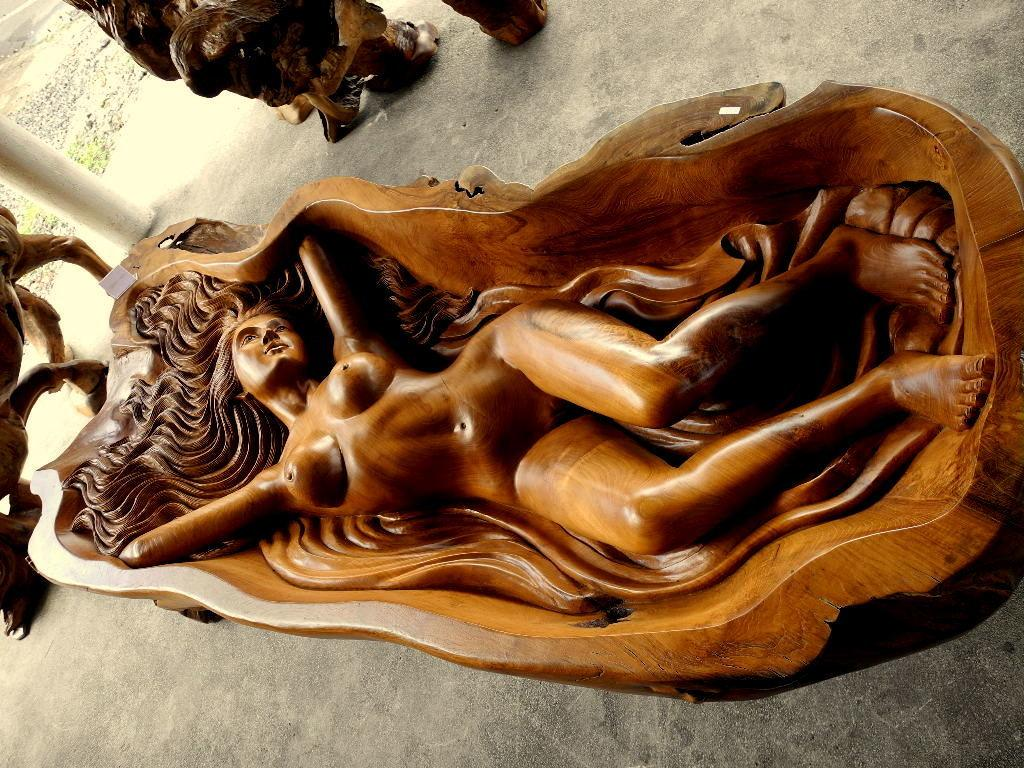What type of object is the main subject in the image? There is a wooden statue in the image. What is the color of the wooden statue? The wooden statue is brown in color. What else can be seen in the background of the image? There are other statues and a pole in the background of the image. What is the color of the pole? The pole is white in color. What type of clocks are hanging on the wall behind the wooden statue? There are no clocks visible in the image; it only features a wooden statue, other statues, and a pole in the background. What selection of bikes is available for purchase in the image? There is no mention of bikes or any selection in the image; it only features a wooden statue and other objects in the background. 